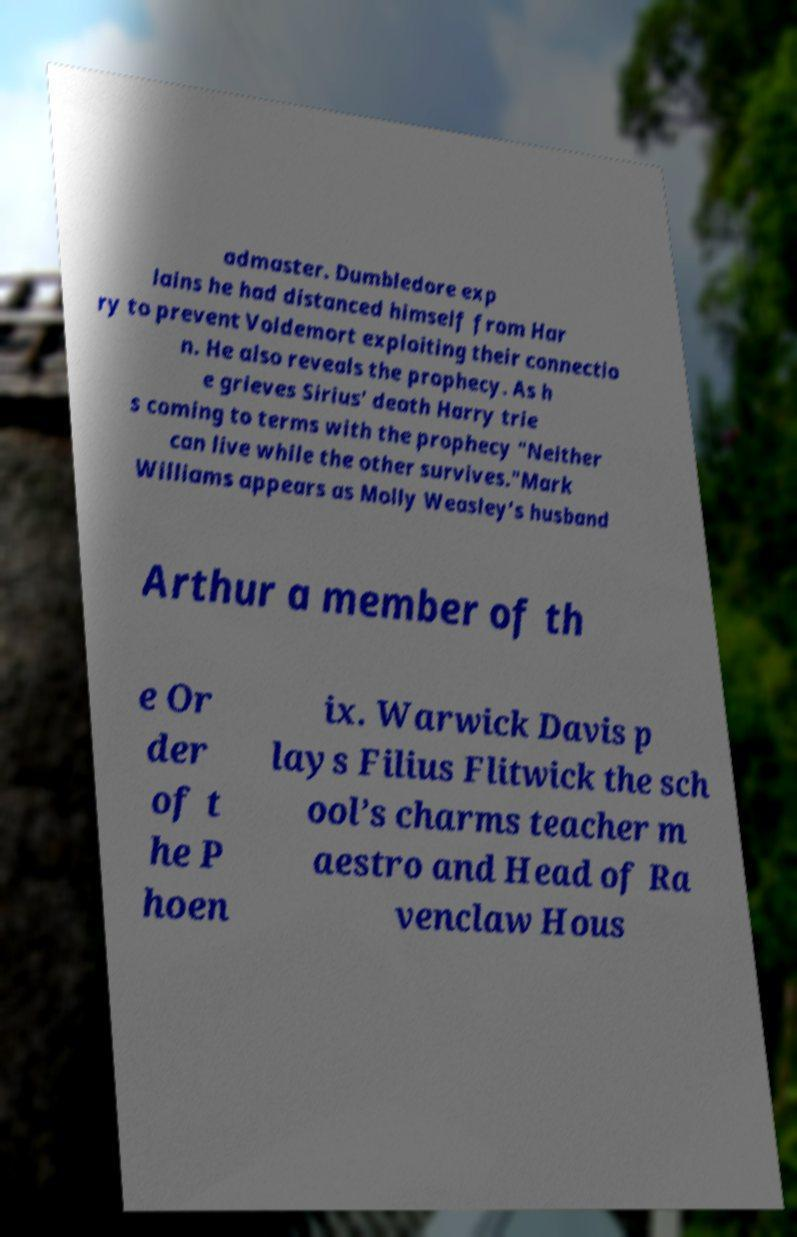Could you assist in decoding the text presented in this image and type it out clearly? admaster. Dumbledore exp lains he had distanced himself from Har ry to prevent Voldemort exploiting their connectio n. He also reveals the prophecy. As h e grieves Sirius' death Harry trie s coming to terms with the prophecy "Neither can live while the other survives."Mark Williams appears as Molly Weasley’s husband Arthur a member of th e Or der of t he P hoen ix. Warwick Davis p lays Filius Flitwick the sch ool’s charms teacher m aestro and Head of Ra venclaw Hous 